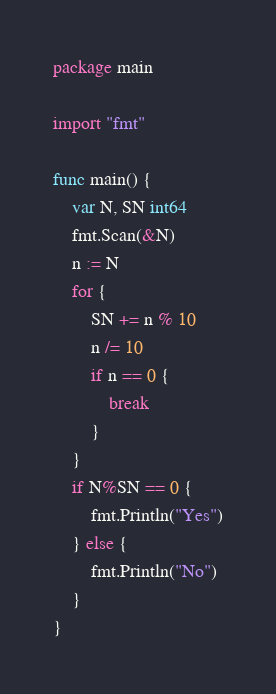Convert code to text. <code><loc_0><loc_0><loc_500><loc_500><_Go_>package main

import "fmt"

func main() {
	var N, SN int64
	fmt.Scan(&N)
	n := N
	for {
		SN += n % 10
		n /= 10
		if n == 0 {
			break
		}
	}
	if N%SN == 0 {
		fmt.Println("Yes")
	} else {
		fmt.Println("No")
	}
}
</code> 